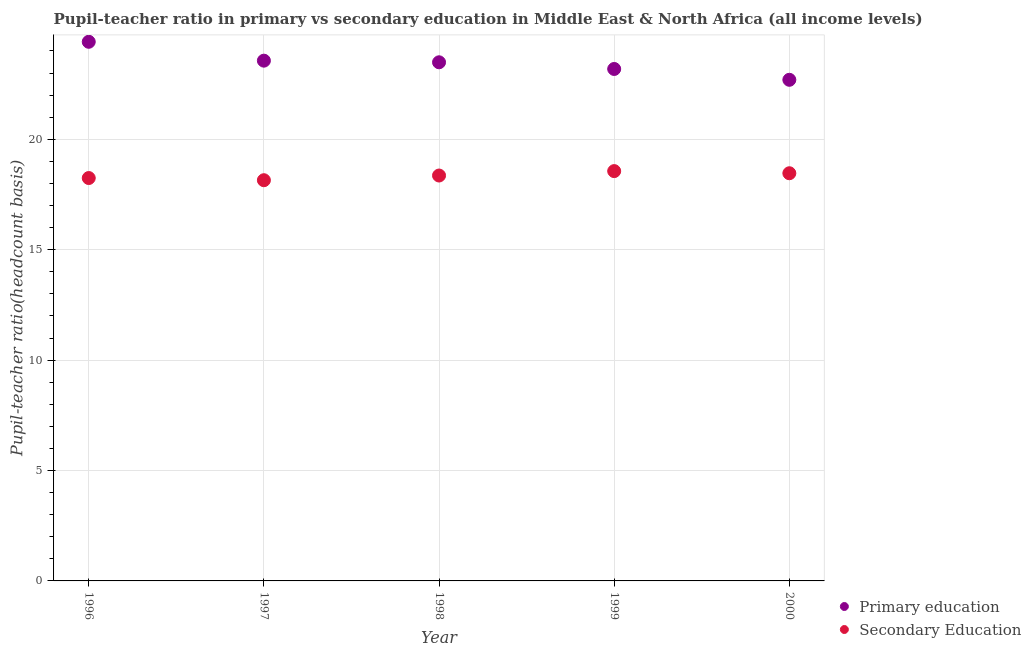Is the number of dotlines equal to the number of legend labels?
Keep it short and to the point. Yes. What is the pupil-teacher ratio in primary education in 1996?
Ensure brevity in your answer.  24.41. Across all years, what is the maximum pupil-teacher ratio in primary education?
Your answer should be very brief. 24.41. Across all years, what is the minimum pupil teacher ratio on secondary education?
Provide a short and direct response. 18.15. In which year was the pupil-teacher ratio in primary education maximum?
Offer a terse response. 1996. What is the total pupil teacher ratio on secondary education in the graph?
Provide a succinct answer. 91.77. What is the difference between the pupil-teacher ratio in primary education in 1998 and that in 1999?
Offer a very short reply. 0.3. What is the difference between the pupil-teacher ratio in primary education in 1997 and the pupil teacher ratio on secondary education in 1999?
Your answer should be compact. 5. What is the average pupil teacher ratio on secondary education per year?
Your answer should be compact. 18.35. In the year 1996, what is the difference between the pupil teacher ratio on secondary education and pupil-teacher ratio in primary education?
Your response must be concise. -6.17. In how many years, is the pupil-teacher ratio in primary education greater than 17?
Your answer should be compact. 5. What is the ratio of the pupil-teacher ratio in primary education in 1996 to that in 1997?
Make the answer very short. 1.04. Is the difference between the pupil-teacher ratio in primary education in 1996 and 1997 greater than the difference between the pupil teacher ratio on secondary education in 1996 and 1997?
Your response must be concise. Yes. What is the difference between the highest and the second highest pupil teacher ratio on secondary education?
Provide a succinct answer. 0.1. What is the difference between the highest and the lowest pupil teacher ratio on secondary education?
Keep it short and to the point. 0.41. In how many years, is the pupil-teacher ratio in primary education greater than the average pupil-teacher ratio in primary education taken over all years?
Make the answer very short. 3. Is the sum of the pupil teacher ratio on secondary education in 1998 and 1999 greater than the maximum pupil-teacher ratio in primary education across all years?
Provide a short and direct response. Yes. How many dotlines are there?
Ensure brevity in your answer.  2. How many years are there in the graph?
Ensure brevity in your answer.  5. What is the difference between two consecutive major ticks on the Y-axis?
Give a very brief answer. 5. What is the title of the graph?
Offer a very short reply. Pupil-teacher ratio in primary vs secondary education in Middle East & North Africa (all income levels). What is the label or title of the X-axis?
Make the answer very short. Year. What is the label or title of the Y-axis?
Keep it short and to the point. Pupil-teacher ratio(headcount basis). What is the Pupil-teacher ratio(headcount basis) of Primary education in 1996?
Offer a very short reply. 24.41. What is the Pupil-teacher ratio(headcount basis) of Secondary Education in 1996?
Make the answer very short. 18.24. What is the Pupil-teacher ratio(headcount basis) of Primary education in 1997?
Provide a short and direct response. 23.56. What is the Pupil-teacher ratio(headcount basis) in Secondary Education in 1997?
Your response must be concise. 18.15. What is the Pupil-teacher ratio(headcount basis) in Primary education in 1998?
Make the answer very short. 23.49. What is the Pupil-teacher ratio(headcount basis) in Secondary Education in 1998?
Provide a succinct answer. 18.36. What is the Pupil-teacher ratio(headcount basis) in Primary education in 1999?
Your response must be concise. 23.18. What is the Pupil-teacher ratio(headcount basis) in Secondary Education in 1999?
Make the answer very short. 18.56. What is the Pupil-teacher ratio(headcount basis) of Primary education in 2000?
Provide a succinct answer. 22.69. What is the Pupil-teacher ratio(headcount basis) of Secondary Education in 2000?
Your answer should be very brief. 18.46. Across all years, what is the maximum Pupil-teacher ratio(headcount basis) in Primary education?
Ensure brevity in your answer.  24.41. Across all years, what is the maximum Pupil-teacher ratio(headcount basis) of Secondary Education?
Provide a short and direct response. 18.56. Across all years, what is the minimum Pupil-teacher ratio(headcount basis) of Primary education?
Your answer should be very brief. 22.69. Across all years, what is the minimum Pupil-teacher ratio(headcount basis) in Secondary Education?
Offer a terse response. 18.15. What is the total Pupil-teacher ratio(headcount basis) in Primary education in the graph?
Your response must be concise. 117.34. What is the total Pupil-teacher ratio(headcount basis) in Secondary Education in the graph?
Your answer should be compact. 91.77. What is the difference between the Pupil-teacher ratio(headcount basis) of Primary education in 1996 and that in 1997?
Keep it short and to the point. 0.85. What is the difference between the Pupil-teacher ratio(headcount basis) of Secondary Education in 1996 and that in 1997?
Your answer should be very brief. 0.1. What is the difference between the Pupil-teacher ratio(headcount basis) in Primary education in 1996 and that in 1998?
Offer a very short reply. 0.93. What is the difference between the Pupil-teacher ratio(headcount basis) of Secondary Education in 1996 and that in 1998?
Your response must be concise. -0.11. What is the difference between the Pupil-teacher ratio(headcount basis) of Primary education in 1996 and that in 1999?
Make the answer very short. 1.23. What is the difference between the Pupil-teacher ratio(headcount basis) in Secondary Education in 1996 and that in 1999?
Provide a short and direct response. -0.31. What is the difference between the Pupil-teacher ratio(headcount basis) in Primary education in 1996 and that in 2000?
Make the answer very short. 1.72. What is the difference between the Pupil-teacher ratio(headcount basis) of Secondary Education in 1996 and that in 2000?
Provide a short and direct response. -0.22. What is the difference between the Pupil-teacher ratio(headcount basis) of Primary education in 1997 and that in 1998?
Keep it short and to the point. 0.07. What is the difference between the Pupil-teacher ratio(headcount basis) of Secondary Education in 1997 and that in 1998?
Ensure brevity in your answer.  -0.21. What is the difference between the Pupil-teacher ratio(headcount basis) of Primary education in 1997 and that in 1999?
Offer a terse response. 0.38. What is the difference between the Pupil-teacher ratio(headcount basis) in Secondary Education in 1997 and that in 1999?
Your response must be concise. -0.41. What is the difference between the Pupil-teacher ratio(headcount basis) of Primary education in 1997 and that in 2000?
Your answer should be very brief. 0.87. What is the difference between the Pupil-teacher ratio(headcount basis) of Secondary Education in 1997 and that in 2000?
Make the answer very short. -0.32. What is the difference between the Pupil-teacher ratio(headcount basis) in Primary education in 1998 and that in 1999?
Provide a short and direct response. 0.3. What is the difference between the Pupil-teacher ratio(headcount basis) in Secondary Education in 1998 and that in 1999?
Provide a short and direct response. -0.2. What is the difference between the Pupil-teacher ratio(headcount basis) of Primary education in 1998 and that in 2000?
Offer a terse response. 0.79. What is the difference between the Pupil-teacher ratio(headcount basis) in Secondary Education in 1998 and that in 2000?
Provide a succinct answer. -0.1. What is the difference between the Pupil-teacher ratio(headcount basis) in Primary education in 1999 and that in 2000?
Keep it short and to the point. 0.49. What is the difference between the Pupil-teacher ratio(headcount basis) of Secondary Education in 1999 and that in 2000?
Give a very brief answer. 0.1. What is the difference between the Pupil-teacher ratio(headcount basis) of Primary education in 1996 and the Pupil-teacher ratio(headcount basis) of Secondary Education in 1997?
Provide a short and direct response. 6.27. What is the difference between the Pupil-teacher ratio(headcount basis) in Primary education in 1996 and the Pupil-teacher ratio(headcount basis) in Secondary Education in 1998?
Your answer should be compact. 6.06. What is the difference between the Pupil-teacher ratio(headcount basis) in Primary education in 1996 and the Pupil-teacher ratio(headcount basis) in Secondary Education in 1999?
Your response must be concise. 5.86. What is the difference between the Pupil-teacher ratio(headcount basis) of Primary education in 1996 and the Pupil-teacher ratio(headcount basis) of Secondary Education in 2000?
Make the answer very short. 5.95. What is the difference between the Pupil-teacher ratio(headcount basis) of Primary education in 1997 and the Pupil-teacher ratio(headcount basis) of Secondary Education in 1998?
Offer a very short reply. 5.2. What is the difference between the Pupil-teacher ratio(headcount basis) in Primary education in 1997 and the Pupil-teacher ratio(headcount basis) in Secondary Education in 1999?
Your answer should be very brief. 5. What is the difference between the Pupil-teacher ratio(headcount basis) in Primary education in 1997 and the Pupil-teacher ratio(headcount basis) in Secondary Education in 2000?
Give a very brief answer. 5.1. What is the difference between the Pupil-teacher ratio(headcount basis) in Primary education in 1998 and the Pupil-teacher ratio(headcount basis) in Secondary Education in 1999?
Give a very brief answer. 4.93. What is the difference between the Pupil-teacher ratio(headcount basis) of Primary education in 1998 and the Pupil-teacher ratio(headcount basis) of Secondary Education in 2000?
Ensure brevity in your answer.  5.02. What is the difference between the Pupil-teacher ratio(headcount basis) in Primary education in 1999 and the Pupil-teacher ratio(headcount basis) in Secondary Education in 2000?
Your answer should be compact. 4.72. What is the average Pupil-teacher ratio(headcount basis) in Primary education per year?
Your answer should be compact. 23.47. What is the average Pupil-teacher ratio(headcount basis) in Secondary Education per year?
Your answer should be compact. 18.35. In the year 1996, what is the difference between the Pupil-teacher ratio(headcount basis) in Primary education and Pupil-teacher ratio(headcount basis) in Secondary Education?
Ensure brevity in your answer.  6.17. In the year 1997, what is the difference between the Pupil-teacher ratio(headcount basis) in Primary education and Pupil-teacher ratio(headcount basis) in Secondary Education?
Offer a very short reply. 5.41. In the year 1998, what is the difference between the Pupil-teacher ratio(headcount basis) in Primary education and Pupil-teacher ratio(headcount basis) in Secondary Education?
Provide a succinct answer. 5.13. In the year 1999, what is the difference between the Pupil-teacher ratio(headcount basis) of Primary education and Pupil-teacher ratio(headcount basis) of Secondary Education?
Offer a very short reply. 4.63. In the year 2000, what is the difference between the Pupil-teacher ratio(headcount basis) in Primary education and Pupil-teacher ratio(headcount basis) in Secondary Education?
Offer a terse response. 4.23. What is the ratio of the Pupil-teacher ratio(headcount basis) in Primary education in 1996 to that in 1997?
Your answer should be very brief. 1.04. What is the ratio of the Pupil-teacher ratio(headcount basis) in Secondary Education in 1996 to that in 1997?
Ensure brevity in your answer.  1.01. What is the ratio of the Pupil-teacher ratio(headcount basis) of Primary education in 1996 to that in 1998?
Make the answer very short. 1.04. What is the ratio of the Pupil-teacher ratio(headcount basis) in Primary education in 1996 to that in 1999?
Make the answer very short. 1.05. What is the ratio of the Pupil-teacher ratio(headcount basis) of Secondary Education in 1996 to that in 1999?
Keep it short and to the point. 0.98. What is the ratio of the Pupil-teacher ratio(headcount basis) of Primary education in 1996 to that in 2000?
Give a very brief answer. 1.08. What is the ratio of the Pupil-teacher ratio(headcount basis) of Secondary Education in 1997 to that in 1998?
Your answer should be very brief. 0.99. What is the ratio of the Pupil-teacher ratio(headcount basis) of Primary education in 1997 to that in 1999?
Keep it short and to the point. 1.02. What is the ratio of the Pupil-teacher ratio(headcount basis) in Secondary Education in 1997 to that in 1999?
Ensure brevity in your answer.  0.98. What is the ratio of the Pupil-teacher ratio(headcount basis) in Primary education in 1997 to that in 2000?
Offer a terse response. 1.04. What is the ratio of the Pupil-teacher ratio(headcount basis) of Secondary Education in 1997 to that in 2000?
Provide a succinct answer. 0.98. What is the ratio of the Pupil-teacher ratio(headcount basis) of Primary education in 1998 to that in 1999?
Provide a succinct answer. 1.01. What is the ratio of the Pupil-teacher ratio(headcount basis) of Primary education in 1998 to that in 2000?
Your response must be concise. 1.03. What is the ratio of the Pupil-teacher ratio(headcount basis) in Secondary Education in 1998 to that in 2000?
Ensure brevity in your answer.  0.99. What is the ratio of the Pupil-teacher ratio(headcount basis) in Primary education in 1999 to that in 2000?
Your answer should be very brief. 1.02. What is the ratio of the Pupil-teacher ratio(headcount basis) of Secondary Education in 1999 to that in 2000?
Your response must be concise. 1.01. What is the difference between the highest and the second highest Pupil-teacher ratio(headcount basis) of Primary education?
Your answer should be compact. 0.85. What is the difference between the highest and the second highest Pupil-teacher ratio(headcount basis) in Secondary Education?
Give a very brief answer. 0.1. What is the difference between the highest and the lowest Pupil-teacher ratio(headcount basis) in Primary education?
Offer a very short reply. 1.72. What is the difference between the highest and the lowest Pupil-teacher ratio(headcount basis) in Secondary Education?
Your answer should be very brief. 0.41. 